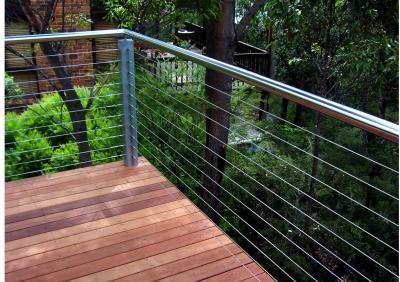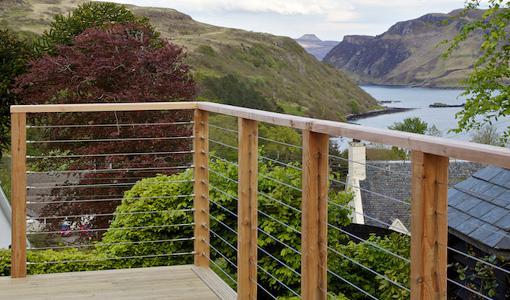The first image is the image on the left, the second image is the image on the right. Given the left and right images, does the statement "The left image shows the corner of a deck with a silver-colored pipe-shaped handrail and thin horizontal metal rods beween upright metal posts." hold true? Answer yes or no. Yes. The first image is the image on the left, the second image is the image on the right. For the images displayed, is the sentence "In at least one image there a is wooden and metal string balcony overlooking the water and trees." factually correct? Answer yes or no. Yes. 